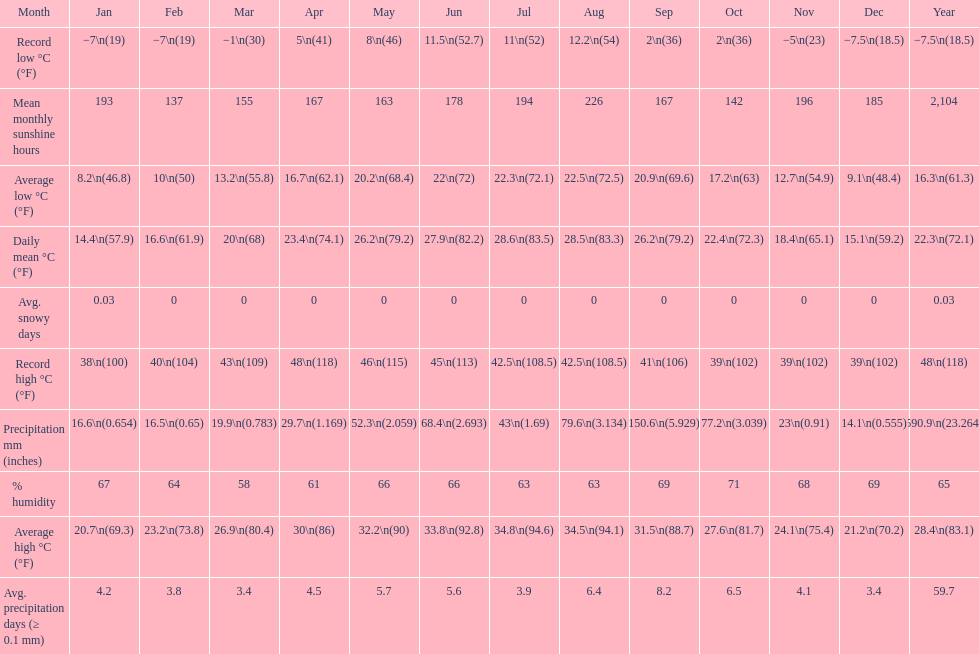Which month had the most sunny days? August. Can you give me this table as a dict? {'header': ['Month', 'Jan', 'Feb', 'Mar', 'Apr', 'May', 'Jun', 'Jul', 'Aug', 'Sep', 'Oct', 'Nov', 'Dec', 'Year'], 'rows': [['Record low °C (°F)', '−7\\n(19)', '−7\\n(19)', '−1\\n(30)', '5\\n(41)', '8\\n(46)', '11.5\\n(52.7)', '11\\n(52)', '12.2\\n(54)', '2\\n(36)', '2\\n(36)', '−5\\n(23)', '−7.5\\n(18.5)', '−7.5\\n(18.5)'], ['Mean monthly sunshine hours', '193', '137', '155', '167', '163', '178', '194', '226', '167', '142', '196', '185', '2,104'], ['Average low °C (°F)', '8.2\\n(46.8)', '10\\n(50)', '13.2\\n(55.8)', '16.7\\n(62.1)', '20.2\\n(68.4)', '22\\n(72)', '22.3\\n(72.1)', '22.5\\n(72.5)', '20.9\\n(69.6)', '17.2\\n(63)', '12.7\\n(54.9)', '9.1\\n(48.4)', '16.3\\n(61.3)'], ['Daily mean °C (°F)', '14.4\\n(57.9)', '16.6\\n(61.9)', '20\\n(68)', '23.4\\n(74.1)', '26.2\\n(79.2)', '27.9\\n(82.2)', '28.6\\n(83.5)', '28.5\\n(83.3)', '26.2\\n(79.2)', '22.4\\n(72.3)', '18.4\\n(65.1)', '15.1\\n(59.2)', '22.3\\n(72.1)'], ['Avg. snowy days', '0.03', '0', '0', '0', '0', '0', '0', '0', '0', '0', '0', '0', '0.03'], ['Record high °C (°F)', '38\\n(100)', '40\\n(104)', '43\\n(109)', '48\\n(118)', '46\\n(115)', '45\\n(113)', '42.5\\n(108.5)', '42.5\\n(108.5)', '41\\n(106)', '39\\n(102)', '39\\n(102)', '39\\n(102)', '48\\n(118)'], ['Precipitation mm (inches)', '16.6\\n(0.654)', '16.5\\n(0.65)', '19.9\\n(0.783)', '29.7\\n(1.169)', '52.3\\n(2.059)', '68.4\\n(2.693)', '43\\n(1.69)', '79.6\\n(3.134)', '150.6\\n(5.929)', '77.2\\n(3.039)', '23\\n(0.91)', '14.1\\n(0.555)', '590.9\\n(23.264)'], ['% humidity', '67', '64', '58', '61', '66', '66', '63', '63', '69', '71', '68', '69', '65'], ['Average high °C (°F)', '20.7\\n(69.3)', '23.2\\n(73.8)', '26.9\\n(80.4)', '30\\n(86)', '32.2\\n(90)', '33.8\\n(92.8)', '34.8\\n(94.6)', '34.5\\n(94.1)', '31.5\\n(88.7)', '27.6\\n(81.7)', '24.1\\n(75.4)', '21.2\\n(70.2)', '28.4\\n(83.1)'], ['Avg. precipitation days (≥ 0.1 mm)', '4.2', '3.8', '3.4', '4.5', '5.7', '5.6', '3.9', '6.4', '8.2', '6.5', '4.1', '3.4', '59.7']]} 